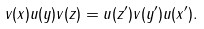Convert formula to latex. <formula><loc_0><loc_0><loc_500><loc_500>v ( x ) u ( y ) v ( z ) = u ( z ^ { \prime } ) v ( y ^ { \prime } ) u ( x ^ { \prime } ) .</formula> 